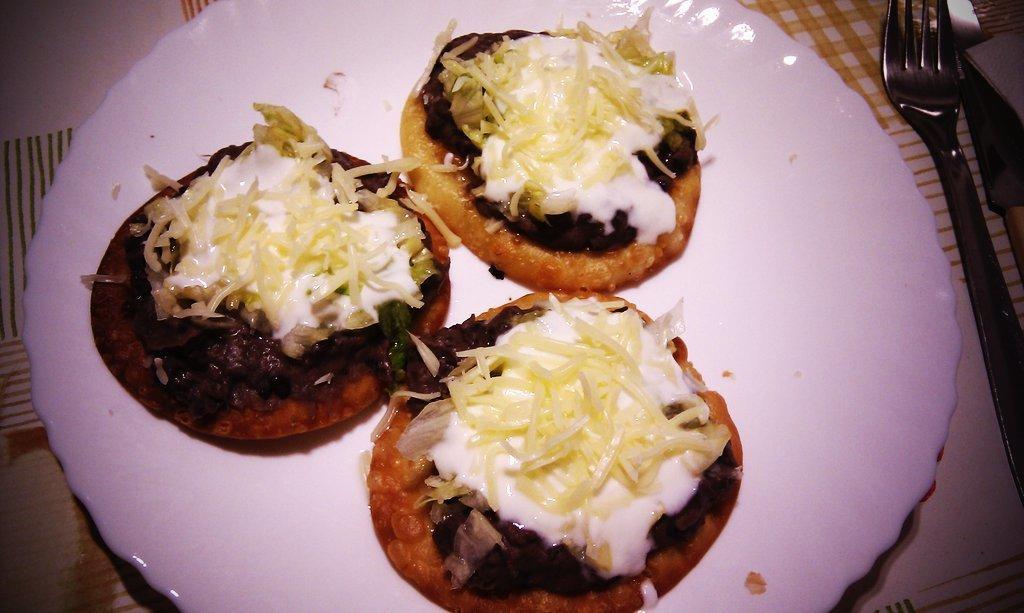In one or two sentences, can you explain what this image depicts? In this image we can see some objects are on the table, one table covered with table cloth, and some food items on the table. 